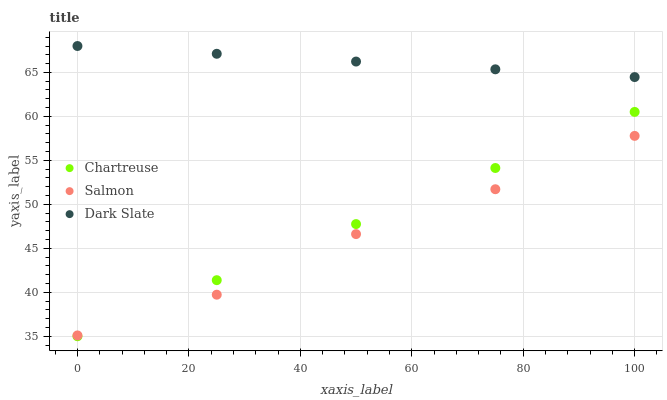Does Salmon have the minimum area under the curve?
Answer yes or no. Yes. Does Dark Slate have the maximum area under the curve?
Answer yes or no. Yes. Does Chartreuse have the minimum area under the curve?
Answer yes or no. No. Does Chartreuse have the maximum area under the curve?
Answer yes or no. No. Is Chartreuse the smoothest?
Answer yes or no. Yes. Is Salmon the roughest?
Answer yes or no. Yes. Is Salmon the smoothest?
Answer yes or no. No. Is Chartreuse the roughest?
Answer yes or no. No. Does Chartreuse have the lowest value?
Answer yes or no. Yes. Does Salmon have the lowest value?
Answer yes or no. No. Does Dark Slate have the highest value?
Answer yes or no. Yes. Does Chartreuse have the highest value?
Answer yes or no. No. Is Salmon less than Dark Slate?
Answer yes or no. Yes. Is Dark Slate greater than Salmon?
Answer yes or no. Yes. Does Chartreuse intersect Salmon?
Answer yes or no. Yes. Is Chartreuse less than Salmon?
Answer yes or no. No. Is Chartreuse greater than Salmon?
Answer yes or no. No. Does Salmon intersect Dark Slate?
Answer yes or no. No. 